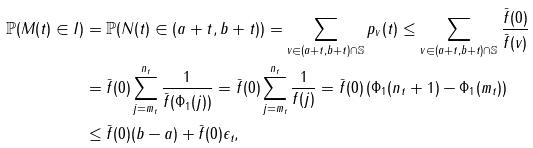Convert formula to latex. <formula><loc_0><loc_0><loc_500><loc_500>\mathbb { P } ( M ( t ) \in I ) & = \mathbb { P } ( N ( t ) \in ( a + t , b + t ) ) = \sum _ { v \in ( a + t , b + t ) \cap \mathbb { S } } p _ { v } ( t ) \leq \sum _ { v \in ( a + t , b + t ) \cap \mathbb { S } } \frac { \bar { f } ( 0 ) } { \bar { f } ( v ) } \\ & = \bar { f } ( 0 ) \sum _ { j = m _ { t } } ^ { n _ { t } } \frac { 1 } { \bar { f } ( \Phi _ { 1 } ( j ) ) } = \bar { f } ( 0 ) \sum _ { j = m _ { t } } ^ { n _ { t } } \frac { 1 } { f ( j ) } = \bar { f } ( 0 ) \left ( \Phi _ { 1 } ( n _ { t } + 1 ) - \Phi _ { 1 } ( m _ { t } ) \right ) \\ & \leq \bar { f } ( 0 ) ( b - a ) + \bar { f } ( 0 ) \epsilon _ { t } ,</formula> 